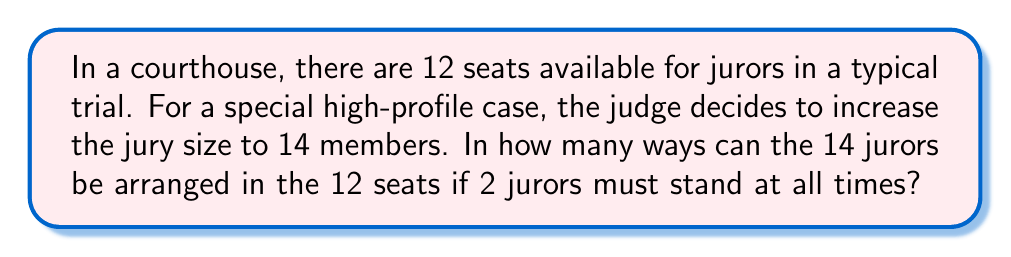Provide a solution to this math problem. Let's approach this step-by-step:

1) First, we need to choose which 2 jurors out of the 14 will stand. This can be done in $\binom{14}{2}$ ways.

2) $\binom{14}{2} = \frac{14!}{2!(14-2)!} = \frac{14!}{2!12!} = 91$

3) After choosing the 2 standing jurors, we need to arrange the remaining 12 jurors in the 12 seats. This is a straightforward permutation of 12 objects, which can be done in 12! ways.

4) By the multiplication principle, the total number of ways to arrange the jurors is:

   $91 \times 12!$

5) Let's calculate this:
   $91 \times 12! = 91 \times 479,001,600 = 43,589,145,600$

Therefore, there are 43,589,145,600 ways to arrange the 14 jurors with 2 standing at all times.
Answer: 43,589,145,600 